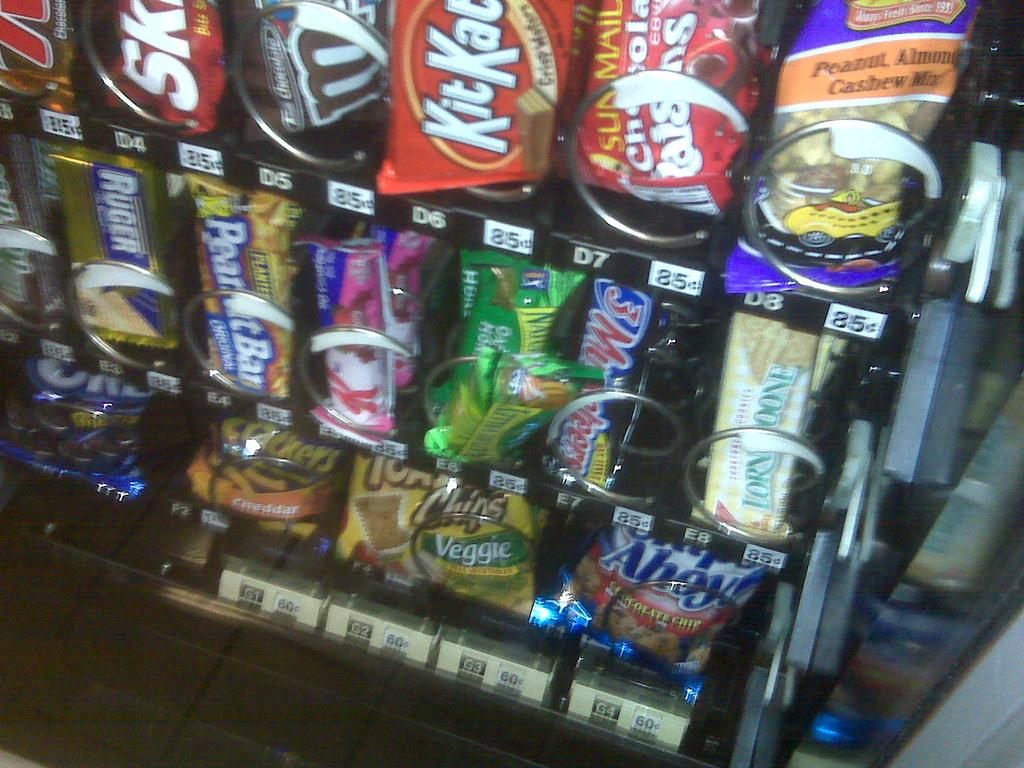What can be seen in the rack in the image? There are food items arranged in the rack. How can the food items be identified in the image? There are labels on the rack to identify the food items. What type of art can be seen hanging on the wall behind the rack? There is no art visible in the image; it only shows a rack with food items and labels. 